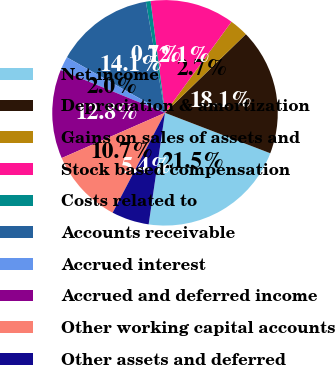Convert chart. <chart><loc_0><loc_0><loc_500><loc_500><pie_chart><fcel>Net income<fcel>Depreciation & amortization<fcel>Gains on sales of assets and<fcel>Stock based compensation<fcel>Costs related to<fcel>Accounts receivable<fcel>Accrued interest<fcel>Accrued and deferred income<fcel>Other working capital accounts<fcel>Other assets and deferred<nl><fcel>21.48%<fcel>18.12%<fcel>2.68%<fcel>12.08%<fcel>0.67%<fcel>14.09%<fcel>2.01%<fcel>12.75%<fcel>10.74%<fcel>5.37%<nl></chart> 